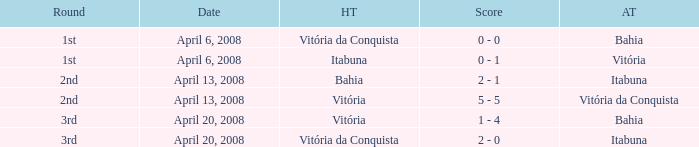Who was the home team on April 13, 2008 when Itabuna was the away team? Bahia. 